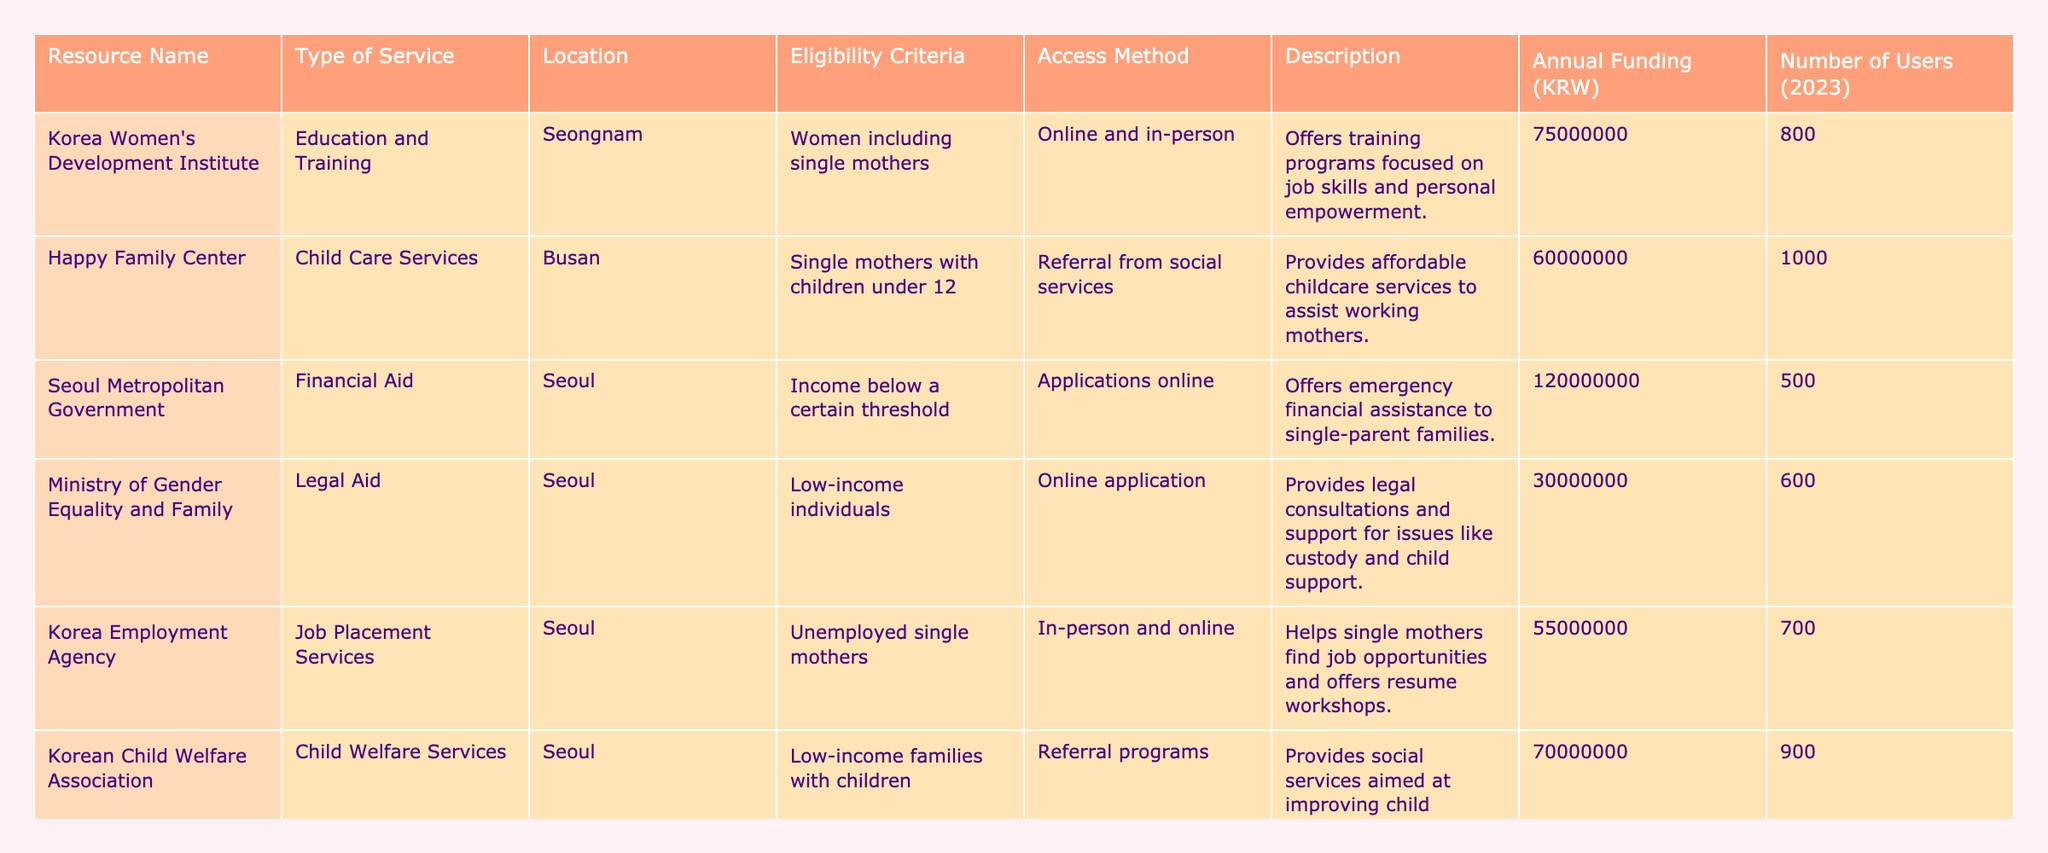What is the total annual funding provided by the Happy Family Center? The annual funding for the Happy Family Center listed in the table is 60,000,000 KRW.
Answer: 60,000,000 KRW Which resource has the highest number of users in 2023? The Happy Family Center has the highest number of users with 1,000 reported users in 2023.
Answer: 1,000 users Is the Korea Employment Agency's service available for all single mothers? The eligibility criteria for the Korea Employment Agency's job placement services are specified as unemployed single mothers, which means it is not open to all single mothers.
Answer: No What is the combined annual funding for the Korea Women's Development Institute and the Korean Child Welfare Association? The annual funding for the Korea Women's Development Institute is 75,000,000 KRW and for the Korean Child Welfare Association is 70,000,000 KRW. The combined total is 75,000,000 + 70,000,000 = 145,000,000 KRW.
Answer: 145,000,000 KRW How many services listed provide support specific to single mothers? From the table, there are 5 services specifically targeting single mothers: Happy Family Center, Seoul Metropolitan Government, Korea Employment Agency, Korean Child Welfare Association, and Ministry of Gender Equality and Family.
Answer: 5 services What percentage of users of the Ministry of Gender Equality and Family's legal aid service is out of the total users across all resources? The total number of users across all resources is 800 + 1,000 + 500 + 600 + 700 + 900 + 400 = 4,100. The Ministry of Gender Equality and Family has 600 users, so the percentage is (600 / 4100) * 100 ≈ 14.63%.
Answer: Approximately 14.63% What types of services are provided in Seoul according to the table? The types of services provided in Seoul include financial aid, legal aid, job placement services, and financial education, making a total of four different types in that location.
Answer: 4 types Which resource has the least annual funding? The resource with the least annual funding is Hana Financial Group, with an annual funding of 15,000,000 KRW.
Answer: 15,000,000 KRW What is the difference in the number of users between the Happy Family Center and the Hana Financial Group? The Happy Family Center has 1,000 users while the Hana Financial Group has 400 users. Therefore, the difference in the number of users is 1,000 - 400 = 600 users.
Answer: 600 users Are all the financial services in the table limited to low-income individuals? Only the Seoul Metropolitan Government's financial aid service and the Ministry of Gender Equality and Family's legal aid service are limited to low-income individuals, while the Hana Financial Group's financial education service is open to all.
Answer: No 